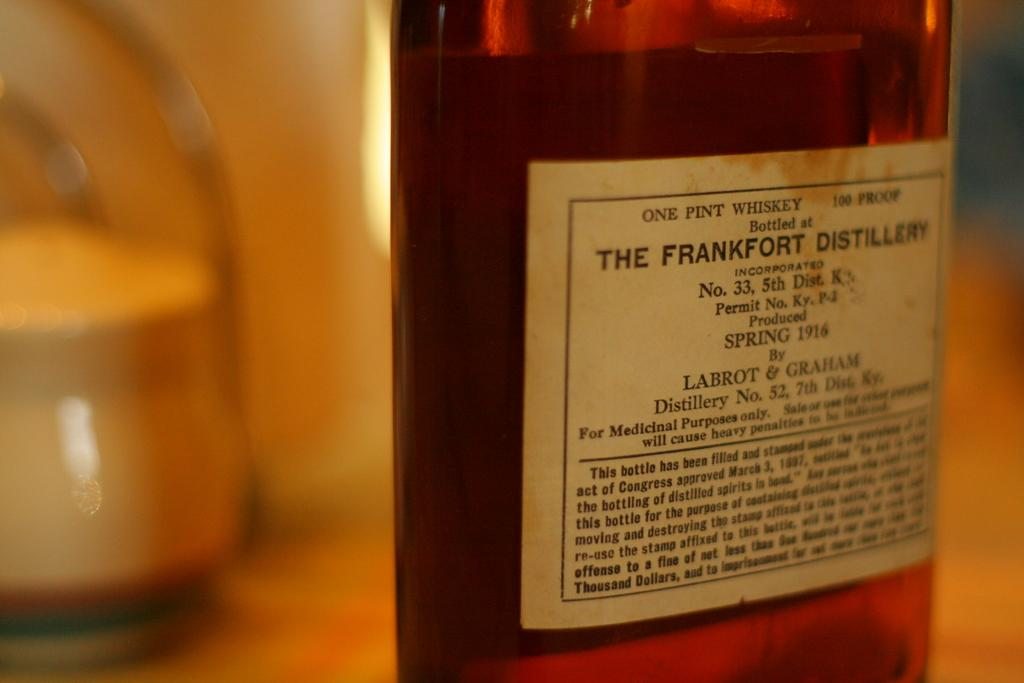Provide a one-sentence caption for the provided image. One pint of whiskey from the Frankfurt Distillery that was produced in Spring 1916 is pictured. 